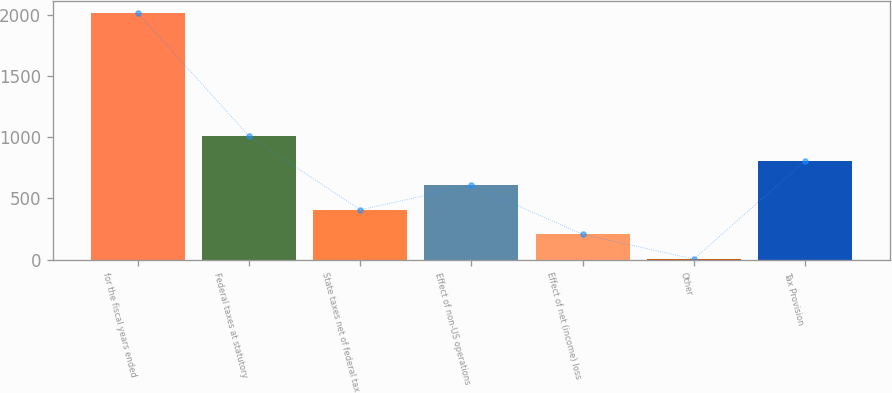Convert chart. <chart><loc_0><loc_0><loc_500><loc_500><bar_chart><fcel>for the fiscal years ended<fcel>Federal taxes at statutory<fcel>State taxes net of federal tax<fcel>Effect of non-US operations<fcel>Effect of net (income) loss<fcel>Other<fcel>Tax Provision<nl><fcel>2017<fcel>1010.8<fcel>407.08<fcel>608.32<fcel>205.84<fcel>4.6<fcel>809.56<nl></chart> 